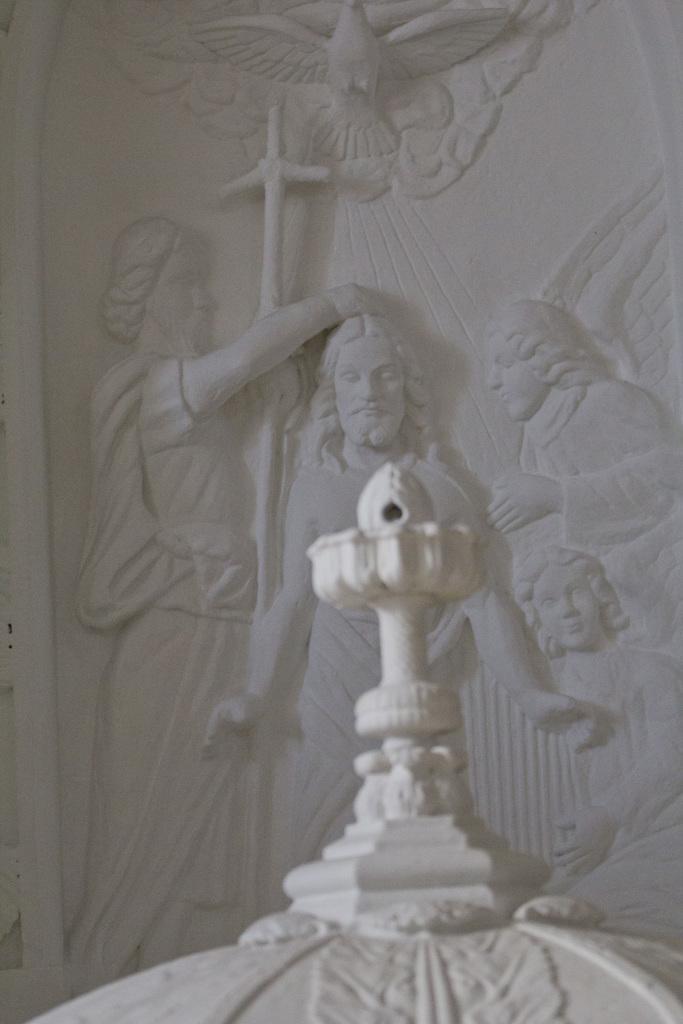Could you give a brief overview of what you see in this image? This image consists of a statue. There is something like Jesus Christ in the middle. 